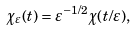<formula> <loc_0><loc_0><loc_500><loc_500>\chi _ { \varepsilon } ( t ) = \varepsilon ^ { - 1 / 2 } \chi ( t / \varepsilon ) ,</formula> 